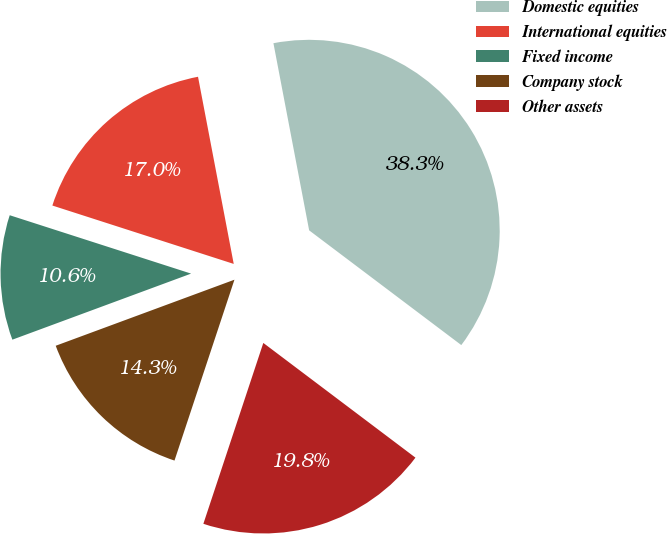<chart> <loc_0><loc_0><loc_500><loc_500><pie_chart><fcel>Domestic equities<fcel>International equities<fcel>Fixed income<fcel>Company stock<fcel>Other assets<nl><fcel>38.28%<fcel>17.04%<fcel>10.59%<fcel>14.27%<fcel>19.81%<nl></chart> 